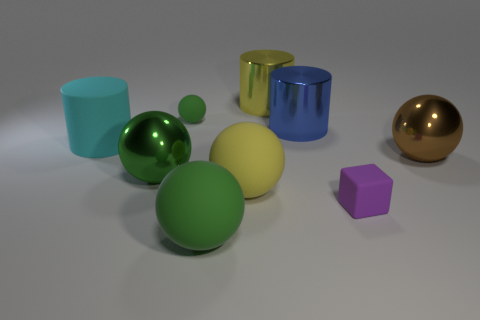Subtract all green balls. How many were subtracted if there are1green balls left? 2 Subtract all large metal cylinders. How many cylinders are left? 1 Add 1 small purple cubes. How many objects exist? 10 Subtract all yellow cylinders. How many cylinders are left? 2 Subtract all gray cylinders. Subtract all purple balls. How many cylinders are left? 3 Subtract all yellow blocks. How many green balls are left? 3 Subtract all large brown things. Subtract all purple things. How many objects are left? 7 Add 8 metal cylinders. How many metal cylinders are left? 10 Add 2 tiny blocks. How many tiny blocks exist? 3 Subtract 0 purple cylinders. How many objects are left? 9 